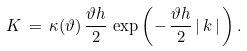<formula> <loc_0><loc_0><loc_500><loc_500>K \, = \, \kappa ( \vartheta ) \, \frac { \vartheta h } { 2 } \, \exp \left ( - \, \frac { \vartheta h } { 2 } \, | \, k \, | \, \right ) .</formula> 